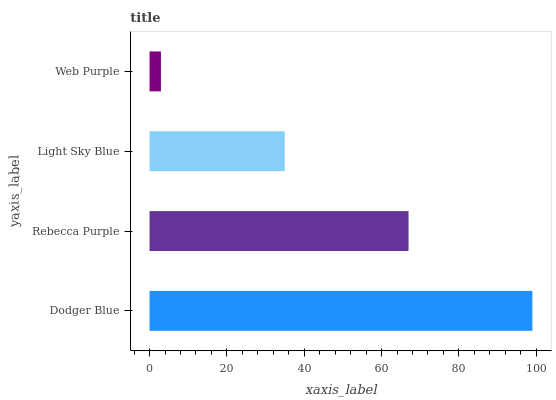Is Web Purple the minimum?
Answer yes or no. Yes. Is Dodger Blue the maximum?
Answer yes or no. Yes. Is Rebecca Purple the minimum?
Answer yes or no. No. Is Rebecca Purple the maximum?
Answer yes or no. No. Is Dodger Blue greater than Rebecca Purple?
Answer yes or no. Yes. Is Rebecca Purple less than Dodger Blue?
Answer yes or no. Yes. Is Rebecca Purple greater than Dodger Blue?
Answer yes or no. No. Is Dodger Blue less than Rebecca Purple?
Answer yes or no. No. Is Rebecca Purple the high median?
Answer yes or no. Yes. Is Light Sky Blue the low median?
Answer yes or no. Yes. Is Dodger Blue the high median?
Answer yes or no. No. Is Web Purple the low median?
Answer yes or no. No. 